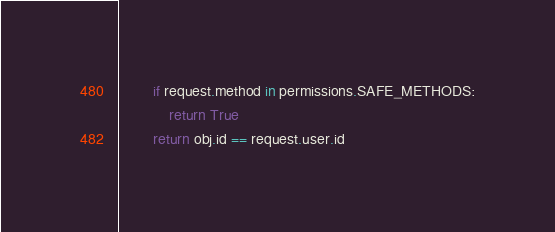<code> <loc_0><loc_0><loc_500><loc_500><_Python_>        if request.method in permissions.SAFE_METHODS:
            return True
        return obj.id == request.user.id
</code> 